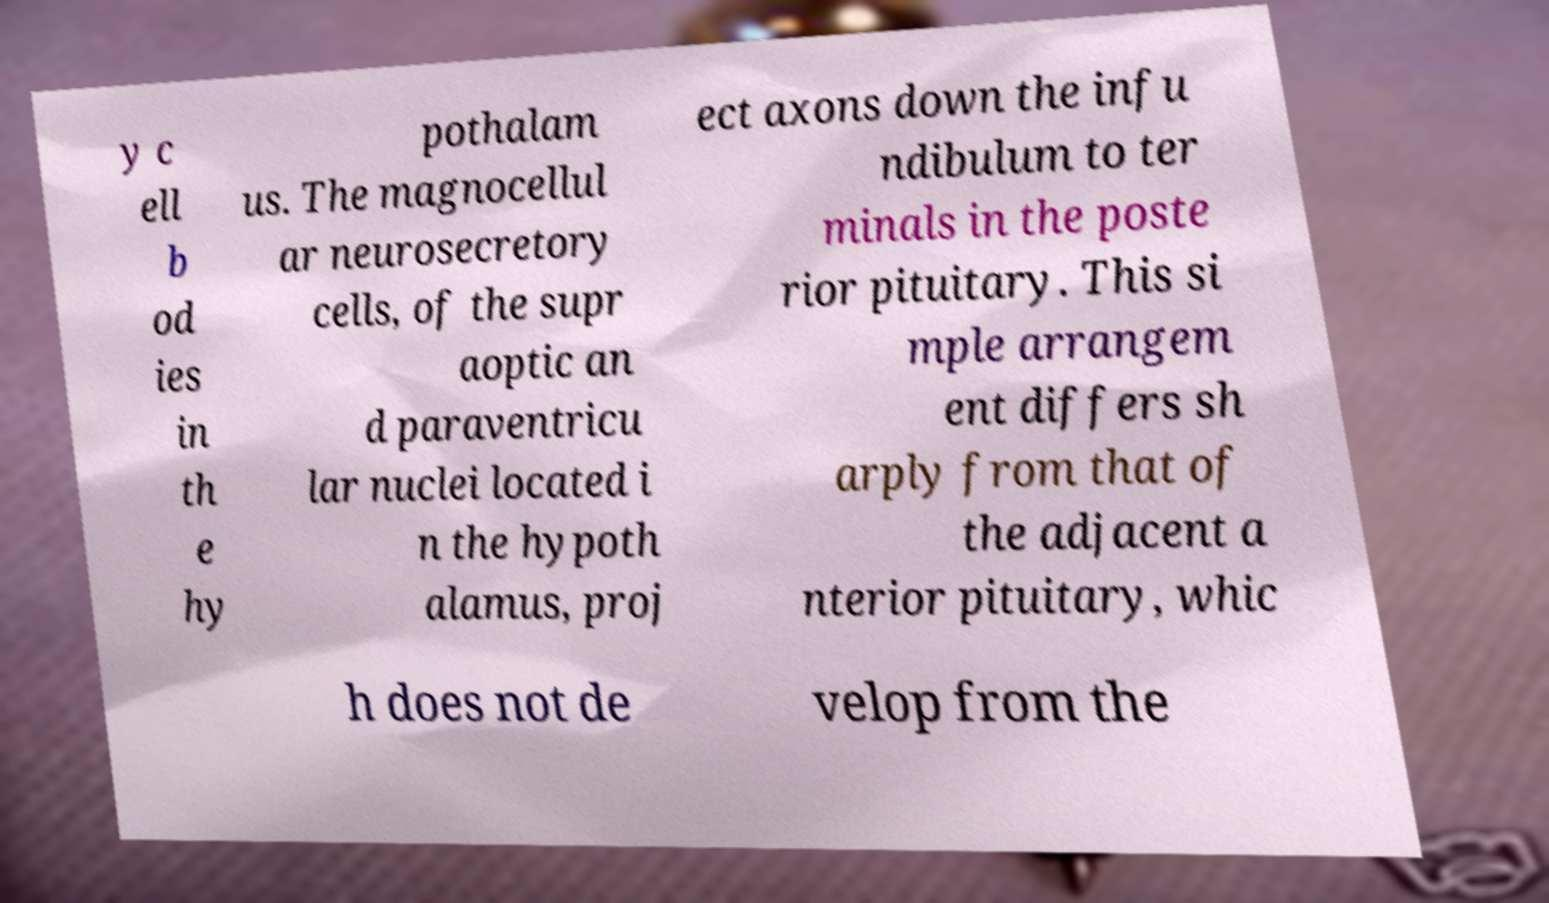Could you assist in decoding the text presented in this image and type it out clearly? y c ell b od ies in th e hy pothalam us. The magnocellul ar neurosecretory cells, of the supr aoptic an d paraventricu lar nuclei located i n the hypoth alamus, proj ect axons down the infu ndibulum to ter minals in the poste rior pituitary. This si mple arrangem ent differs sh arply from that of the adjacent a nterior pituitary, whic h does not de velop from the 